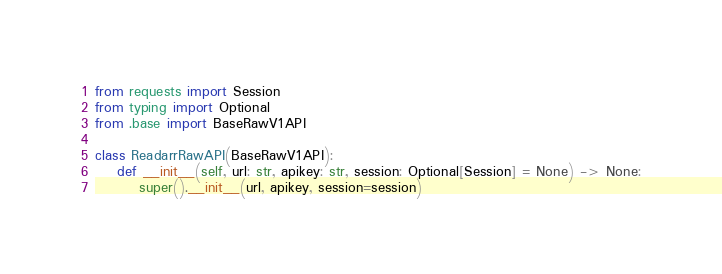<code> <loc_0><loc_0><loc_500><loc_500><_Python_>from requests import Session
from typing import Optional
from .base import BaseRawV1API

class ReadarrRawAPI(BaseRawV1API):
    def __init__(self, url: str, apikey: str, session: Optional[Session] = None) -> None:
        super().__init__(url, apikey, session=session)
</code> 